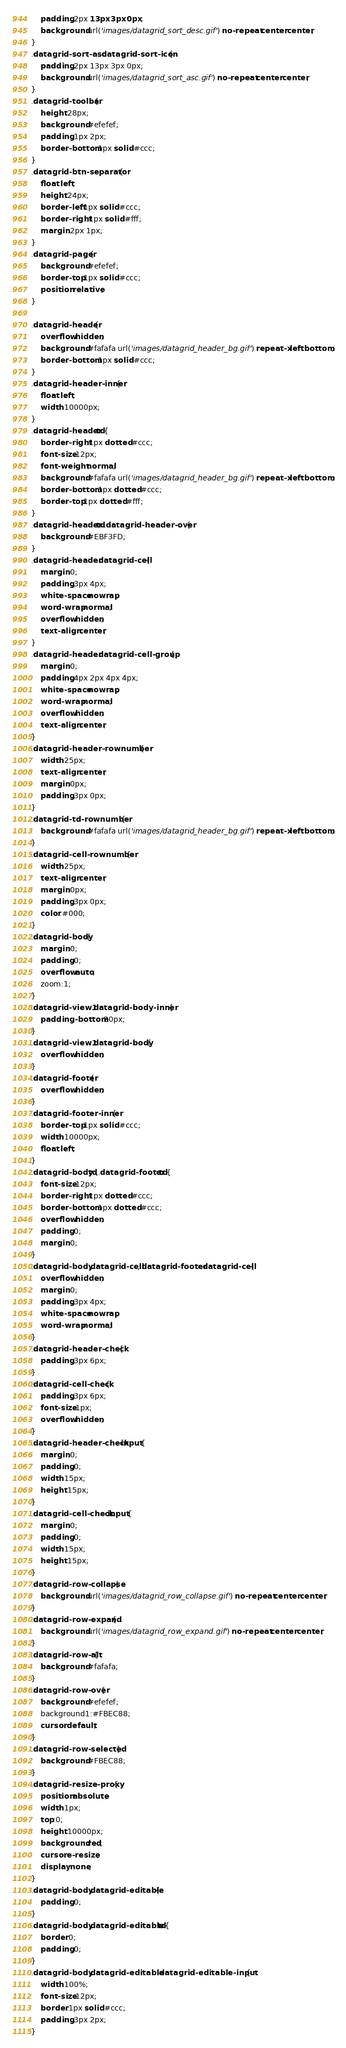Convert code to text. <code><loc_0><loc_0><loc_500><loc_500><_CSS_>	padding:2px 13px 3px 0px;
	background:url('images/datagrid_sort_desc.gif') no-repeat center center;
}
.datagrid-sort-asc .datagrid-sort-icon{
	padding:2px 13px 3px 0px;
	background:url('images/datagrid_sort_asc.gif') no-repeat center center;
}
.datagrid-toolbar{
	height:28px;
	background:#efefef;
	padding:1px 2px;
	border-bottom:1px solid #ccc;
}
.datagrid-btn-separator{
	float:left;
	height:24px;
	border-left:1px solid #ccc;
	border-right:1px solid #fff;
	margin:2px 1px;
}
.datagrid-pager{
	background:#efefef;
	border-top:1px solid #ccc;
	position:relative;
}

.datagrid-header{
	overflow:hidden;
	background:#fafafa url('images/datagrid_header_bg.gif') repeat-x left bottom;
	border-bottom:1px solid #ccc;
}
.datagrid-header-inner{
	float:left;
	width:10000px;
}
.datagrid-header td{
	border-right:1px dotted #ccc;
	font-size:12px;
	font-weight:normal;
	background:#fafafa url('images/datagrid_header_bg.gif') repeat-x left bottom;
	border-bottom:1px dotted #ccc;
	border-top:1px dotted #fff;
}
.datagrid-header td.datagrid-header-over{
	background:#EBF3FD;
}
.datagrid-header .datagrid-cell{
	margin:0;
	padding:3px 4px;
	white-space:nowrap;
	word-wrap:normal;
	overflow:hidden;
	text-align:center;
}
.datagrid-header .datagrid-cell-group{
	margin:0;
	padding:4px 2px 4px 4px;
	white-space:nowrap;
	word-wrap:normal;
	overflow:hidden;
	text-align:center;
}
.datagrid-header-rownumber{
	width:25px;
	text-align:center;
	margin:0px;
	padding:3px 0px;
}
.datagrid-td-rownumber{
	background:#fafafa url('images/datagrid_header_bg.gif') repeat-x left bottom;
}
.datagrid-cell-rownumber{
	width:25px;
	text-align:center;
	margin:0px;
	padding:3px 0px;
	color:#000;
}
.datagrid-body{
	margin:0;
	padding:0;
	overflow:auto;
	zoom:1;
}
.datagrid-view1 .datagrid-body-inner{
	padding-bottom:20px;
}
.datagrid-view1 .datagrid-body{
	overflow:hidden;
}
.datagrid-footer{
	overflow:hidden;
}
.datagrid-footer-inner{
	border-top:1px solid #ccc;
	width:10000px;
	float:left;
}
.datagrid-body td,.datagrid-footer td{
	font-size:12px;
	border-right:1px dotted #ccc;
	border-bottom:1px dotted #ccc;
	overflow:hidden;
	padding:0;
	margin:0;
}
.datagrid-body .datagrid-cell,.datagrid-footer .datagrid-cell{
	overflow:hidden;
	margin:0;
	padding:3px 4px;
	white-space:nowrap;
	word-wrap:normal;
}
.datagrid-header-check{
	padding:3px 6px;
}
.datagrid-cell-check{
	padding:3px 6px;
	font-size:1px;
	overflow:hidden;
}
.datagrid-header-check input{
	margin:0;
	padding:0;
	width:15px;
	height:15px;
}
.datagrid-cell-check input{
	margin:0;
	padding:0;
	width:15px;
	height:15px;
}
.datagrid-row-collapse{
	background:url('images/datagrid_row_collapse.gif') no-repeat center center;
}
.datagrid-row-expand{
	background:url('images/datagrid_row_expand.gif') no-repeat center center;
}
.datagrid-row-alt{
	background:#fafafa;
}
.datagrid-row-over{
	background:#efefef;
	background1:#FBEC88;
	cursor:default;
}
.datagrid-row-selected{
	background:#FBEC88;
}
.datagrid-resize-proxy{
	position:absolute;
	width:1px;
	top:0;
	height:10000px;
	background:red;
	cursor:e-resize;
	display:none;
}
.datagrid-body .datagrid-editable{
	padding:0;
}
.datagrid-body .datagrid-editable td{
	border:0;
	padding:0;
}
.datagrid-body .datagrid-editable .datagrid-editable-input{
	width:100%;
	font-size:12px;
	border:1px solid #ccc;
	padding:3px 2px;
}</code> 